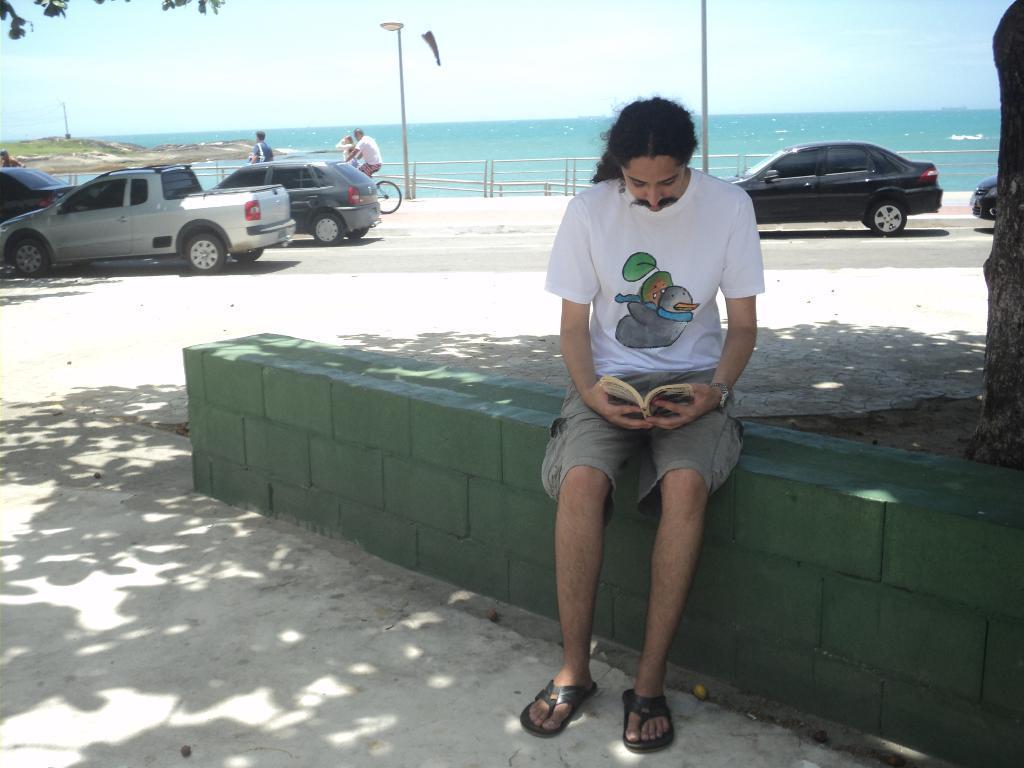How would you summarize this image in a sentence or two? In this image I can see a person wearing white t shirt, grey shirt and black colored footwear is sitting and holding a book in his hand. In the background I can see few cars on the road, few persons standing and a person riding bicycle, the railing, few street light poles, the water, a tree and the sky. 